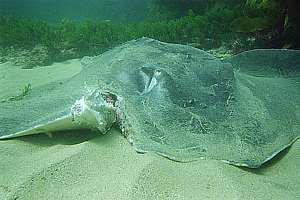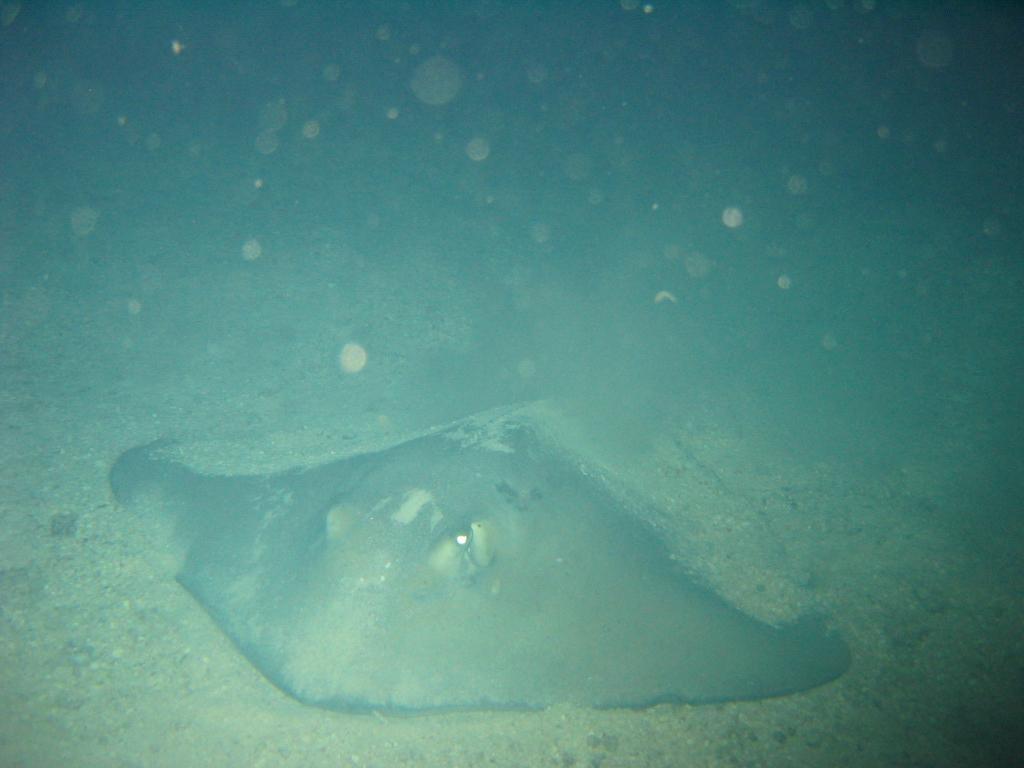The first image is the image on the left, the second image is the image on the right. Given the left and right images, does the statement "The left image shows a Stingray swimming through the water." hold true? Answer yes or no. No. The first image is the image on the left, the second image is the image on the right. Considering the images on both sides, is "All of the stingrays are laying on the ocean floor." valid? Answer yes or no. Yes. 